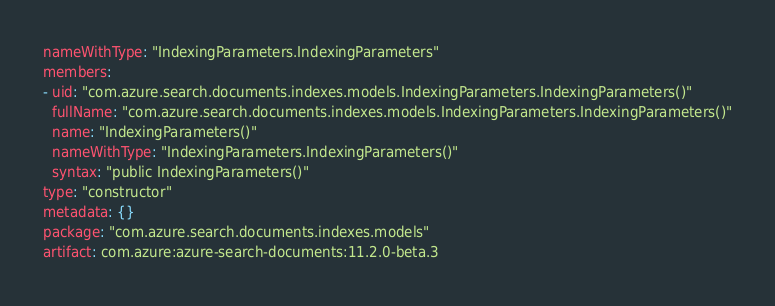Convert code to text. <code><loc_0><loc_0><loc_500><loc_500><_YAML_>nameWithType: "IndexingParameters.IndexingParameters"
members:
- uid: "com.azure.search.documents.indexes.models.IndexingParameters.IndexingParameters()"
  fullName: "com.azure.search.documents.indexes.models.IndexingParameters.IndexingParameters()"
  name: "IndexingParameters()"
  nameWithType: "IndexingParameters.IndexingParameters()"
  syntax: "public IndexingParameters()"
type: "constructor"
metadata: {}
package: "com.azure.search.documents.indexes.models"
artifact: com.azure:azure-search-documents:11.2.0-beta.3
</code> 